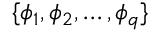<formula> <loc_0><loc_0><loc_500><loc_500>\{ \phi _ { 1 } , \phi _ { 2 } , \dots , \phi _ { q } \}</formula> 